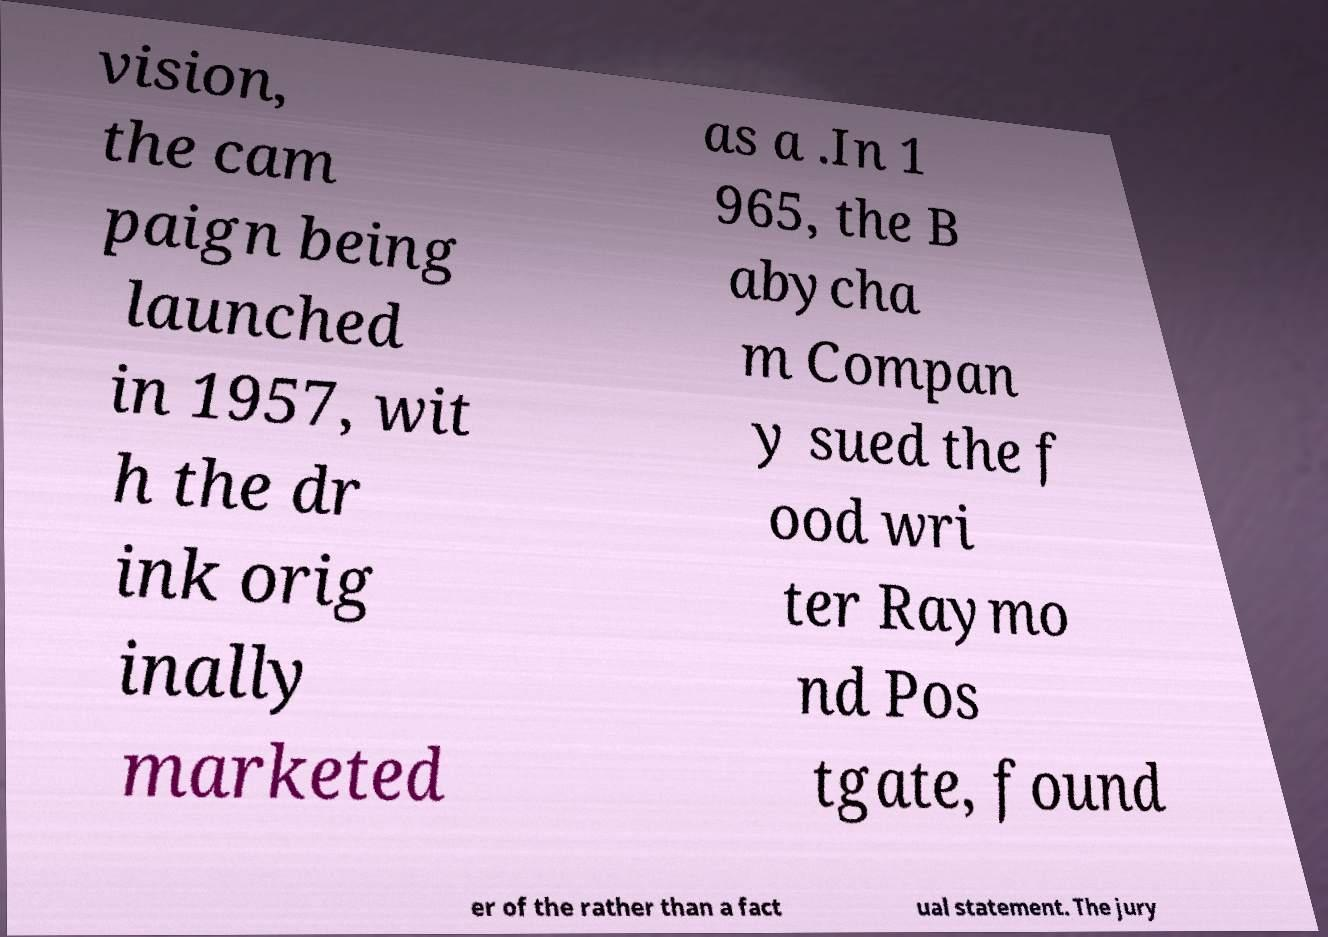For documentation purposes, I need the text within this image transcribed. Could you provide that? vision, the cam paign being launched in 1957, wit h the dr ink orig inally marketed as a .In 1 965, the B abycha m Compan y sued the f ood wri ter Raymo nd Pos tgate, found er of the rather than a fact ual statement. The jury 